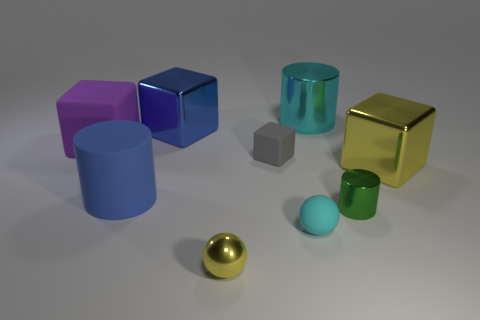There is a small object that is the same color as the big shiny cylinder; what material is it? The small object sharing the same color as the large, shiny cylinder appears to be a rubber ball, given its size and matte finish which contrasts with the reflective metallic sheen of the cylinder. 